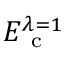Convert formula to latex. <formula><loc_0><loc_0><loc_500><loc_500>E _ { c } ^ { \lambda = 1 }</formula> 